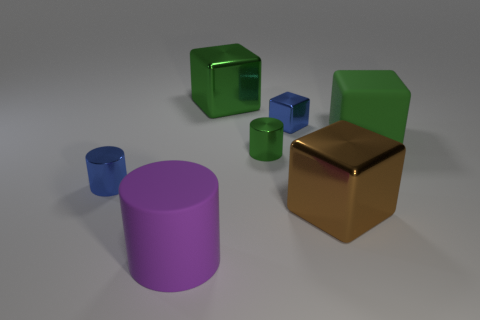Imagine these objects are part of a kid's toy set, what games could they play with them? Children could use these objects to play sorting games, categorizing them by color or shape. Alternatively, they could also use them for imaginative play, pretending the cylinder is a tower and the cubes are buildings in a cityscape, or even creating an obstacle course for toy figures to navigate around. 